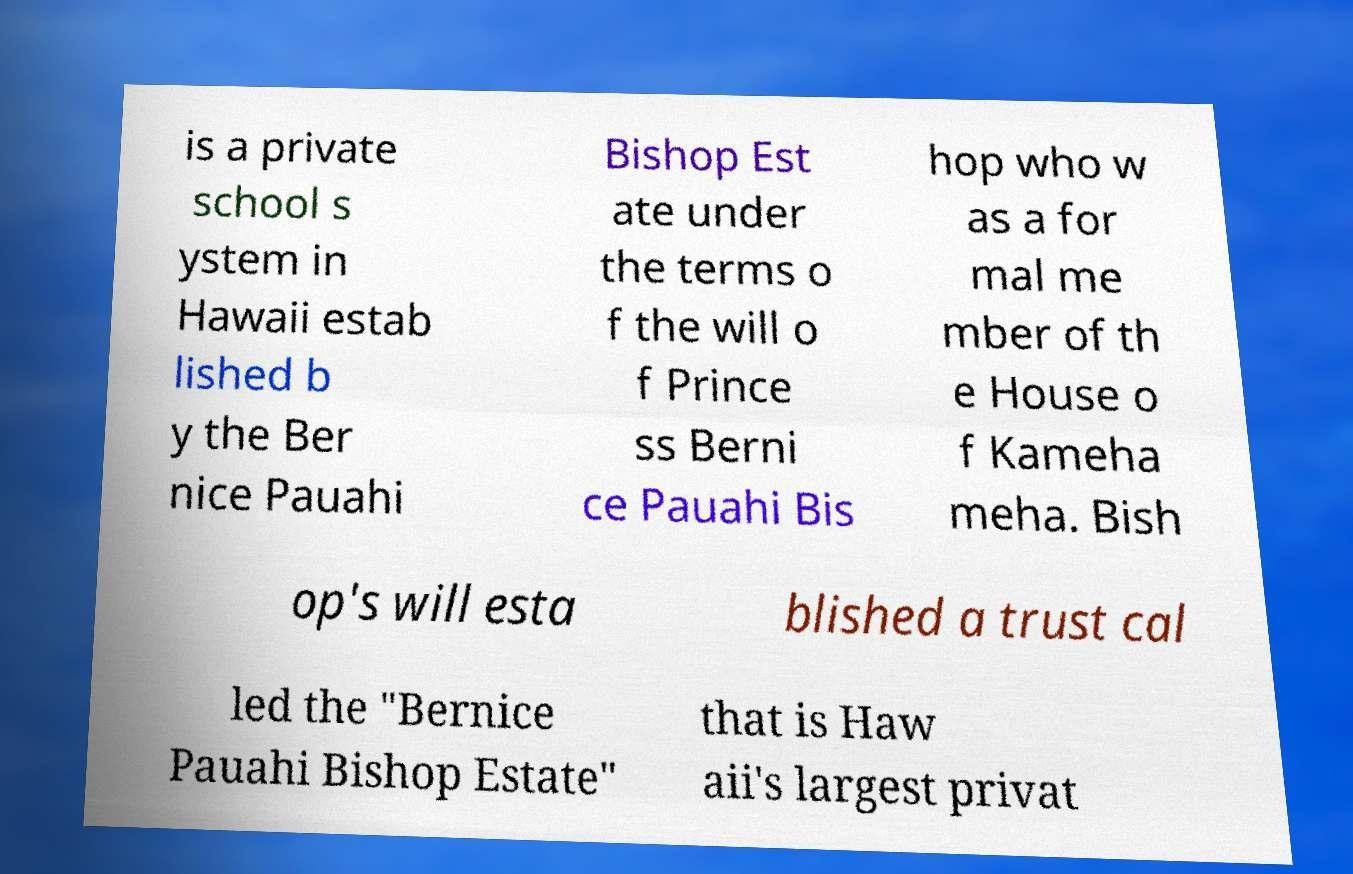Please identify and transcribe the text found in this image. is a private school s ystem in Hawaii estab lished b y the Ber nice Pauahi Bishop Est ate under the terms o f the will o f Prince ss Berni ce Pauahi Bis hop who w as a for mal me mber of th e House o f Kameha meha. Bish op's will esta blished a trust cal led the "Bernice Pauahi Bishop Estate" that is Haw aii's largest privat 